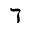Convert formula to latex. <formula><loc_0><loc_0><loc_500><loc_500>\daleth</formula> 